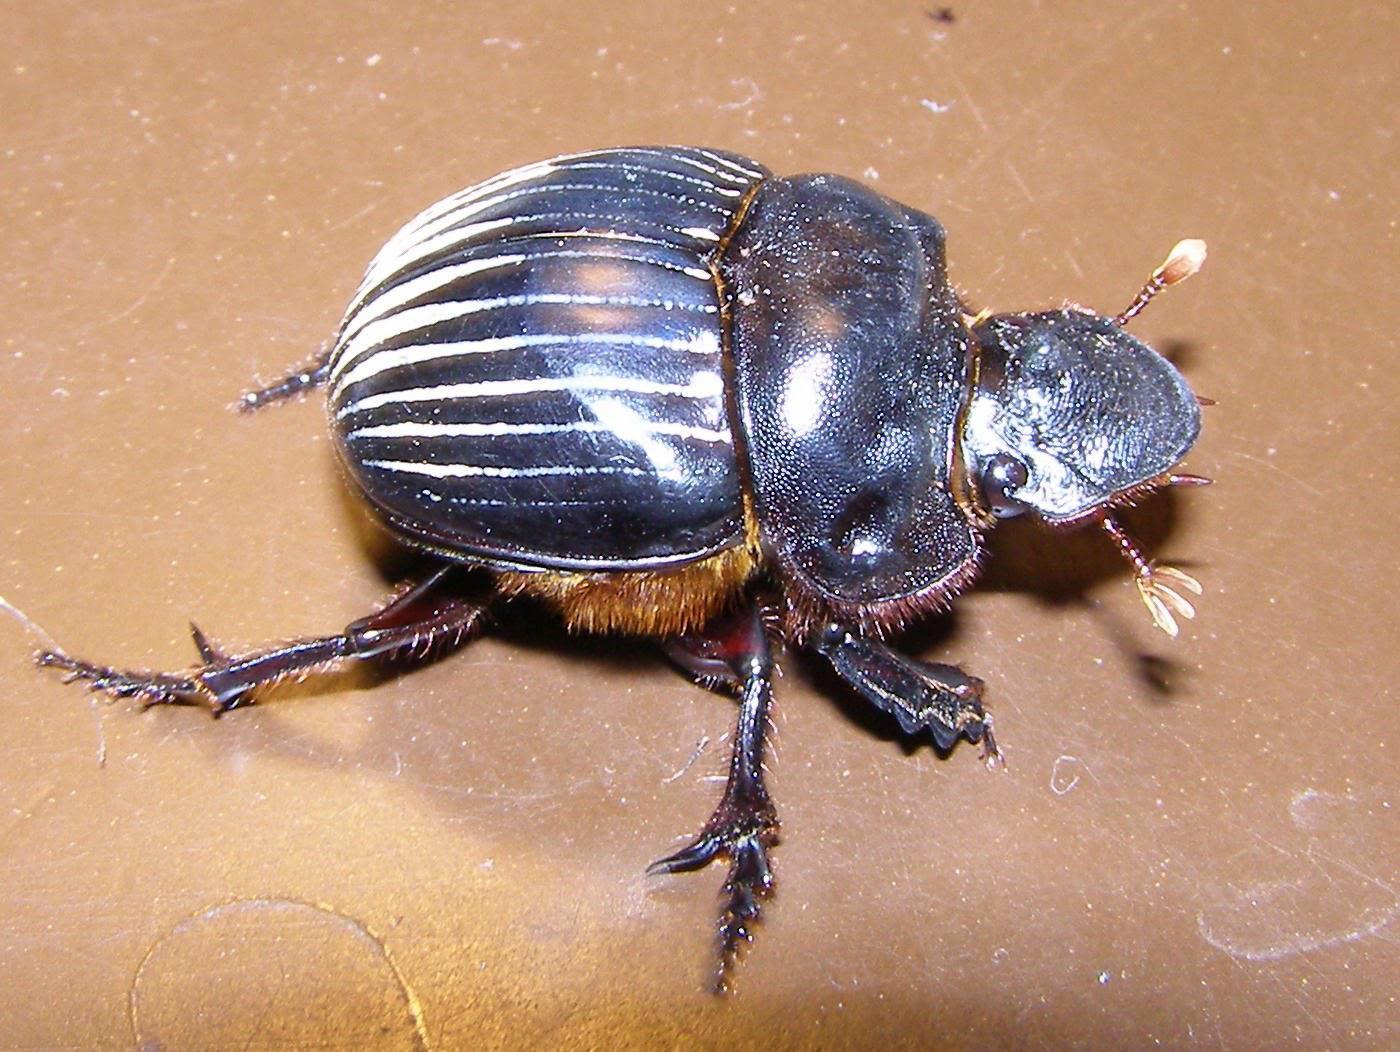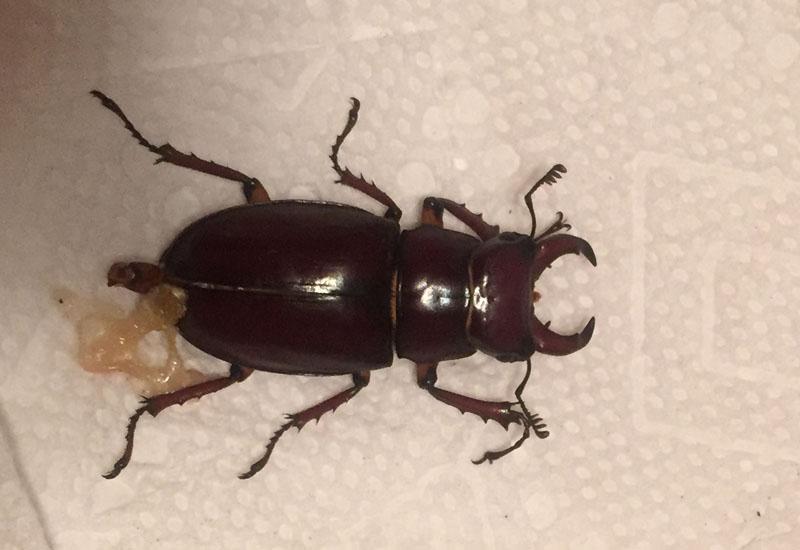The first image is the image on the left, the second image is the image on the right. For the images displayed, is the sentence "A beetle is pictured with a ball of dug." factually correct? Answer yes or no. No. The first image is the image on the left, the second image is the image on the right. Assess this claim about the two images: "there is a ball of dung in the right pic". Correct or not? Answer yes or no. No. 